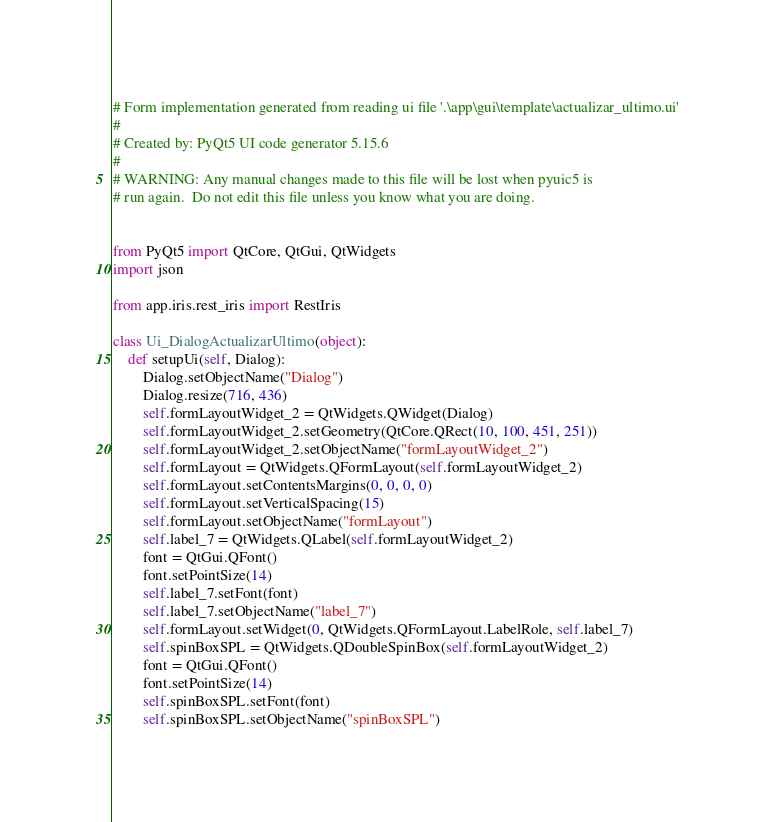Convert code to text. <code><loc_0><loc_0><loc_500><loc_500><_Python_># Form implementation generated from reading ui file '.\app\gui\template\actualizar_ultimo.ui'
#
# Created by: PyQt5 UI code generator 5.15.6
#
# WARNING: Any manual changes made to this file will be lost when pyuic5 is
# run again.  Do not edit this file unless you know what you are doing.


from PyQt5 import QtCore, QtGui, QtWidgets
import json

from app.iris.rest_iris import RestIris

class Ui_DialogActualizarUltimo(object):
    def setupUi(self, Dialog):
        Dialog.setObjectName("Dialog")
        Dialog.resize(716, 436)
        self.formLayoutWidget_2 = QtWidgets.QWidget(Dialog)
        self.formLayoutWidget_2.setGeometry(QtCore.QRect(10, 100, 451, 251))
        self.formLayoutWidget_2.setObjectName("formLayoutWidget_2")
        self.formLayout = QtWidgets.QFormLayout(self.formLayoutWidget_2)
        self.formLayout.setContentsMargins(0, 0, 0, 0)
        self.formLayout.setVerticalSpacing(15)
        self.formLayout.setObjectName("formLayout")
        self.label_7 = QtWidgets.QLabel(self.formLayoutWidget_2)
        font = QtGui.QFont()
        font.setPointSize(14)
        self.label_7.setFont(font)
        self.label_7.setObjectName("label_7")
        self.formLayout.setWidget(0, QtWidgets.QFormLayout.LabelRole, self.label_7)
        self.spinBoxSPL = QtWidgets.QDoubleSpinBox(self.formLayoutWidget_2)
        font = QtGui.QFont()
        font.setPointSize(14)
        self.spinBoxSPL.setFont(font)
        self.spinBoxSPL.setObjectName("spinBoxSPL")</code> 